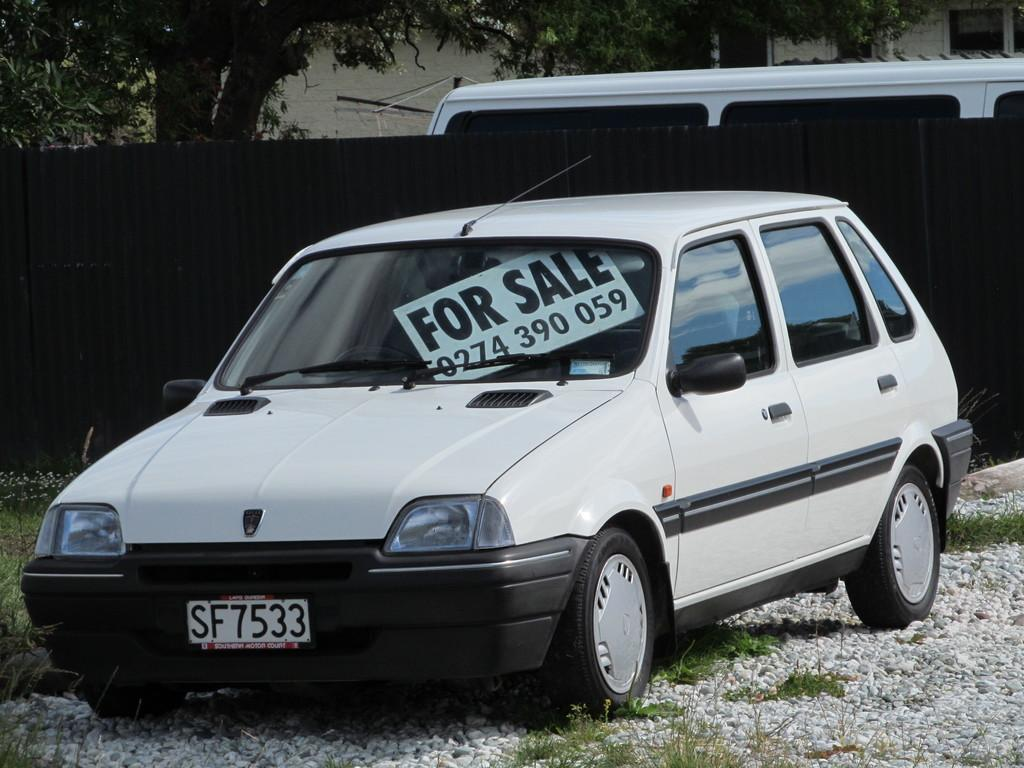<image>
Create a compact narrative representing the image presented. A white car parked in gravel has a sign in the window that says For Sale. 